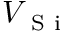Convert formula to latex. <formula><loc_0><loc_0><loc_500><loc_500>V _ { S i }</formula> 